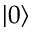Convert formula to latex. <formula><loc_0><loc_0><loc_500><loc_500>| 0 \rangle</formula> 